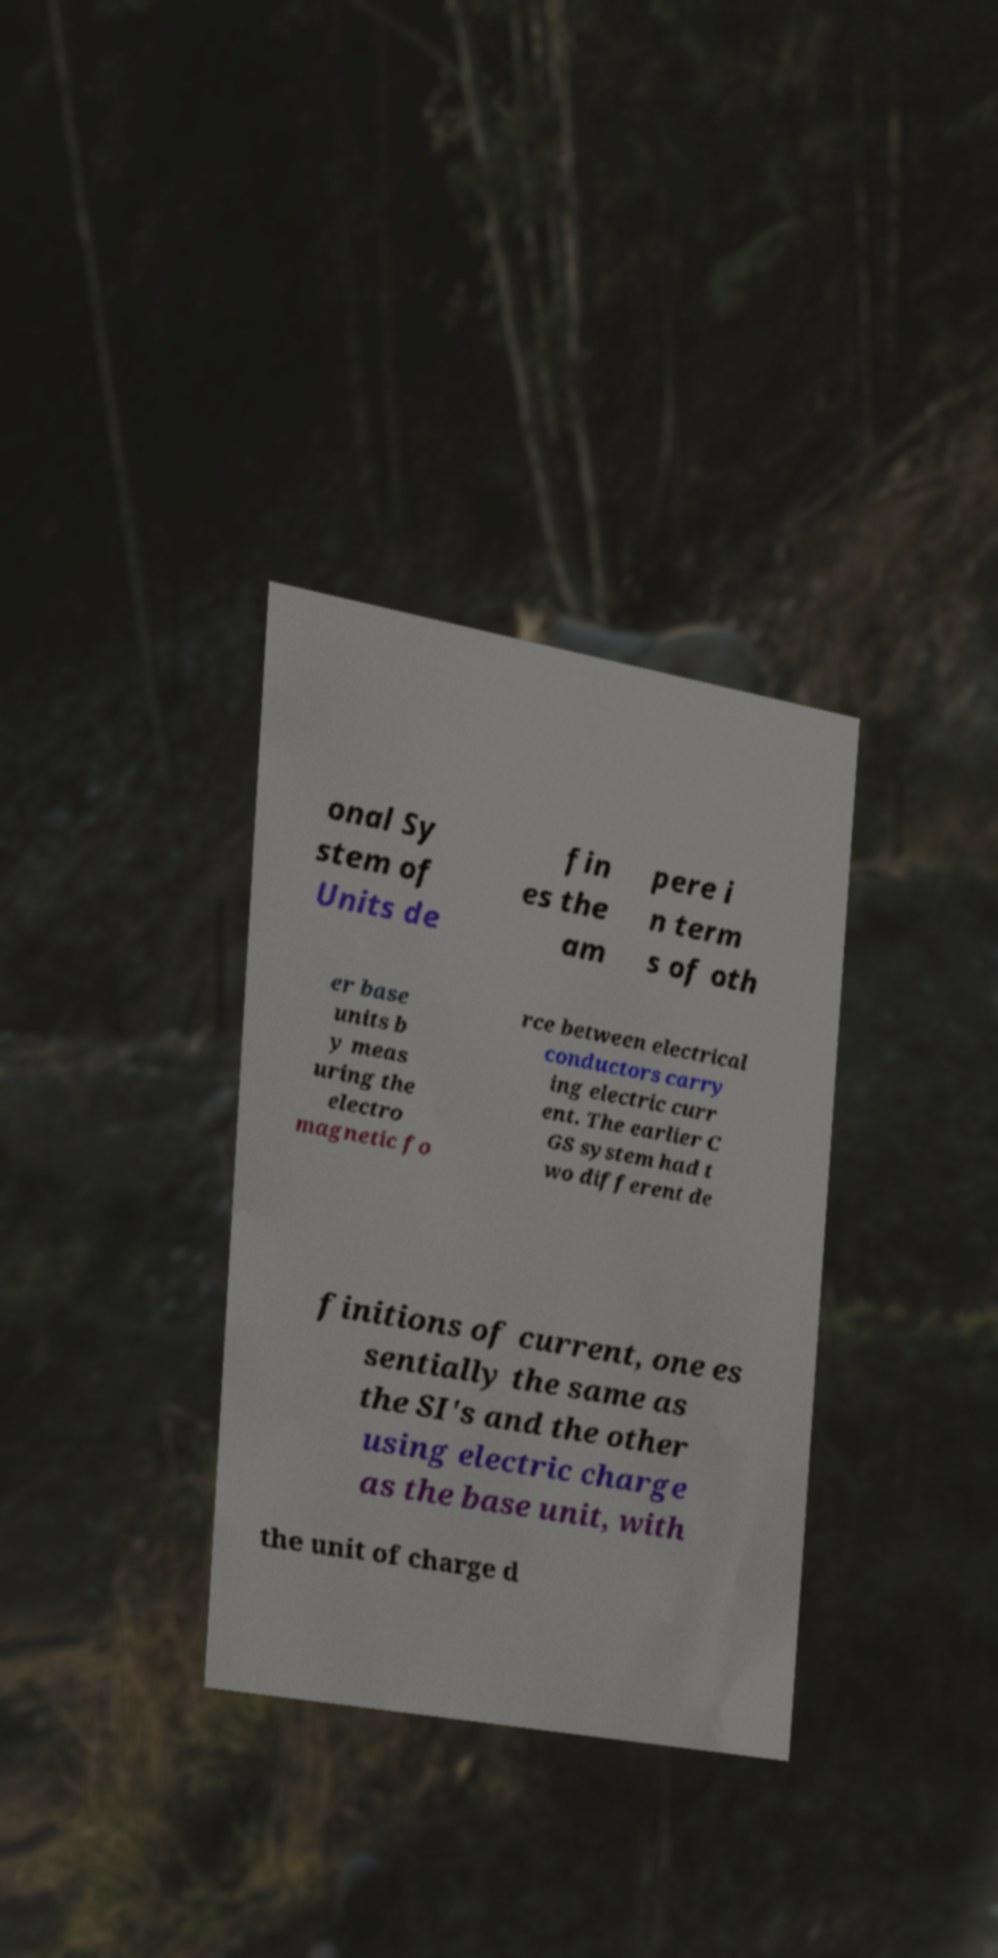Please identify and transcribe the text found in this image. onal Sy stem of Units de fin es the am pere i n term s of oth er base units b y meas uring the electro magnetic fo rce between electrical conductors carry ing electric curr ent. The earlier C GS system had t wo different de finitions of current, one es sentially the same as the SI's and the other using electric charge as the base unit, with the unit of charge d 